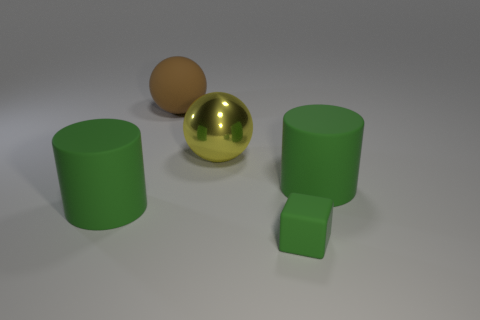Are there more gray matte cylinders than large green objects?
Provide a short and direct response. No. What material is the brown thing?
Your answer should be very brief. Rubber. How many other things are the same material as the large brown sphere?
Your answer should be very brief. 3. How many blue blocks are there?
Ensure brevity in your answer.  0. There is a brown object that is the same shape as the big yellow metallic thing; what is it made of?
Provide a short and direct response. Rubber. Is the material of the big green cylinder that is on the right side of the large rubber ball the same as the block?
Make the answer very short. Yes. Is the number of large things that are in front of the brown matte sphere greater than the number of large brown balls to the right of the large yellow metal object?
Give a very brief answer. Yes. The brown matte sphere has what size?
Offer a very short reply. Large. What shape is the small green thing that is made of the same material as the brown thing?
Your response must be concise. Cube. Do the big green rubber object left of the brown ball and the tiny rubber object have the same shape?
Your response must be concise. No. 